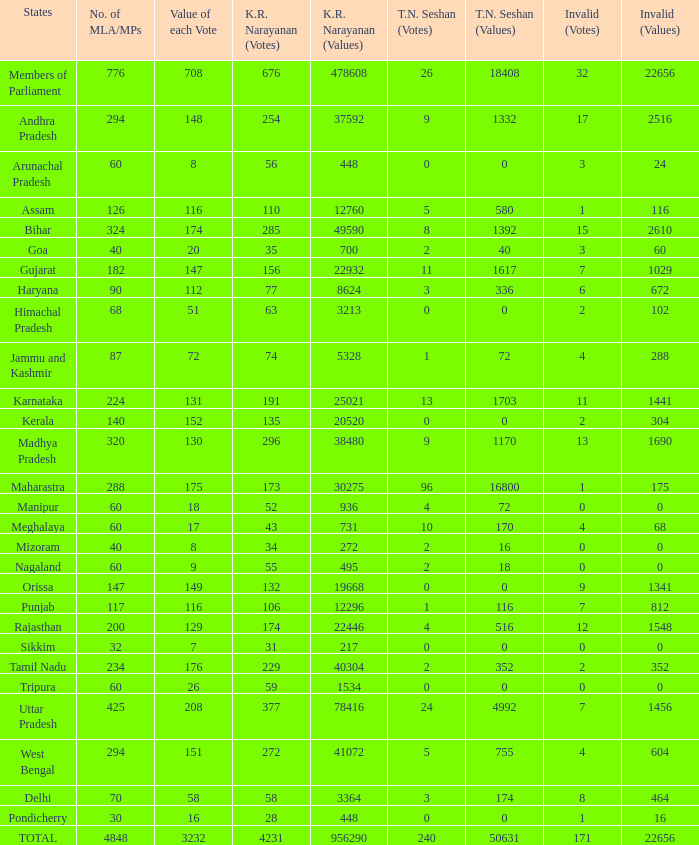What is the highest kr value per vote for a total of 208 votes? 377.0. 